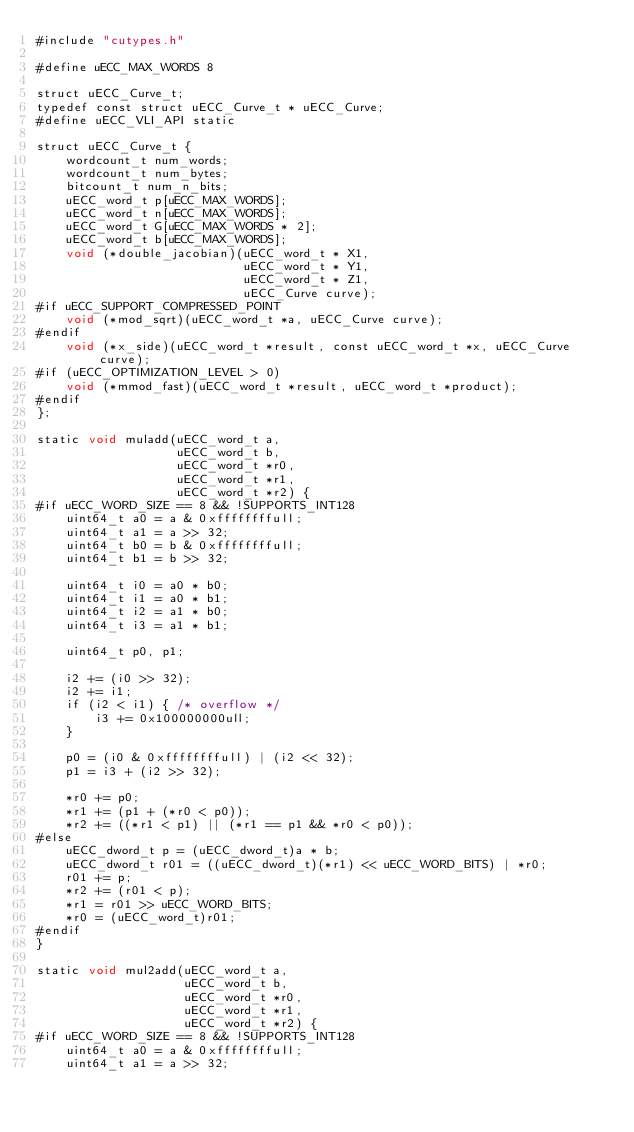<code> <loc_0><loc_0><loc_500><loc_500><_Cuda_>#include "cutypes.h"

#define uECC_MAX_WORDS 8

struct uECC_Curve_t;
typedef const struct uECC_Curve_t * uECC_Curve;
#define uECC_VLI_API static

struct uECC_Curve_t {
    wordcount_t num_words;
    wordcount_t num_bytes;
    bitcount_t num_n_bits;
    uECC_word_t p[uECC_MAX_WORDS];
    uECC_word_t n[uECC_MAX_WORDS];
    uECC_word_t G[uECC_MAX_WORDS * 2];
    uECC_word_t b[uECC_MAX_WORDS];
    void (*double_jacobian)(uECC_word_t * X1,
                            uECC_word_t * Y1,
                            uECC_word_t * Z1,
                            uECC_Curve curve);
#if uECC_SUPPORT_COMPRESSED_POINT
    void (*mod_sqrt)(uECC_word_t *a, uECC_Curve curve);
#endif
    void (*x_side)(uECC_word_t *result, const uECC_word_t *x, uECC_Curve curve);
#if (uECC_OPTIMIZATION_LEVEL > 0)
    void (*mmod_fast)(uECC_word_t *result, uECC_word_t *product);
#endif
};

static void muladd(uECC_word_t a,
                   uECC_word_t b,
                   uECC_word_t *r0,
                   uECC_word_t *r1,
                   uECC_word_t *r2) {
#if uECC_WORD_SIZE == 8 && !SUPPORTS_INT128
    uint64_t a0 = a & 0xffffffffull;
    uint64_t a1 = a >> 32;
    uint64_t b0 = b & 0xffffffffull;
    uint64_t b1 = b >> 32;

    uint64_t i0 = a0 * b0;
    uint64_t i1 = a0 * b1;
    uint64_t i2 = a1 * b0;
    uint64_t i3 = a1 * b1;

    uint64_t p0, p1;

    i2 += (i0 >> 32);
    i2 += i1;
    if (i2 < i1) { /* overflow */
        i3 += 0x100000000ull;
    }

    p0 = (i0 & 0xffffffffull) | (i2 << 32);
    p1 = i3 + (i2 >> 32);

    *r0 += p0;
    *r1 += (p1 + (*r0 < p0));
    *r2 += ((*r1 < p1) || (*r1 == p1 && *r0 < p0));
#else
    uECC_dword_t p = (uECC_dword_t)a * b;
    uECC_dword_t r01 = ((uECC_dword_t)(*r1) << uECC_WORD_BITS) | *r0;
    r01 += p;
    *r2 += (r01 < p);
    *r1 = r01 >> uECC_WORD_BITS;
    *r0 = (uECC_word_t)r01;
#endif
}

static void mul2add(uECC_word_t a,
                    uECC_word_t b,
                    uECC_word_t *r0,
                    uECC_word_t *r1,
                    uECC_word_t *r2) {
#if uECC_WORD_SIZE == 8 && !SUPPORTS_INT128
    uint64_t a0 = a & 0xffffffffull;
    uint64_t a1 = a >> 32;</code> 